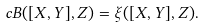Convert formula to latex. <formula><loc_0><loc_0><loc_500><loc_500>c B ( [ X , Y ] , Z ) = \xi ( [ X , Y ] , Z ) .</formula> 